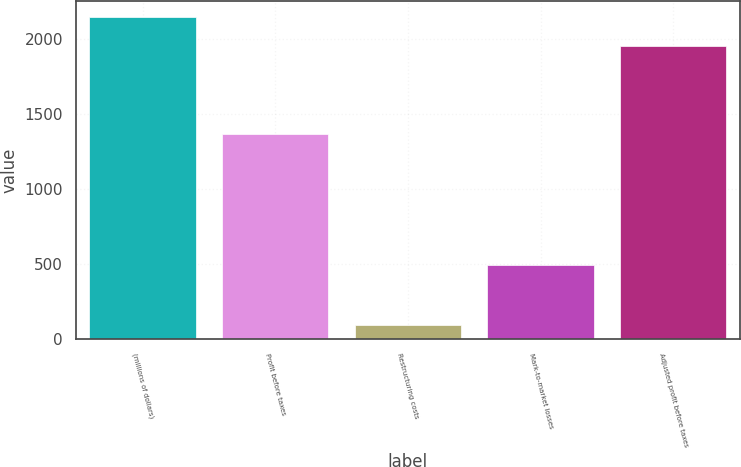Convert chart to OTSL. <chart><loc_0><loc_0><loc_500><loc_500><bar_chart><fcel>(millions of dollars)<fcel>Profit before taxes<fcel>Restructuring costs<fcel>Mark-to-market losses<fcel>Adjusted profit before taxes<nl><fcel>2147.5<fcel>1367<fcel>93<fcel>495<fcel>1955<nl></chart> 